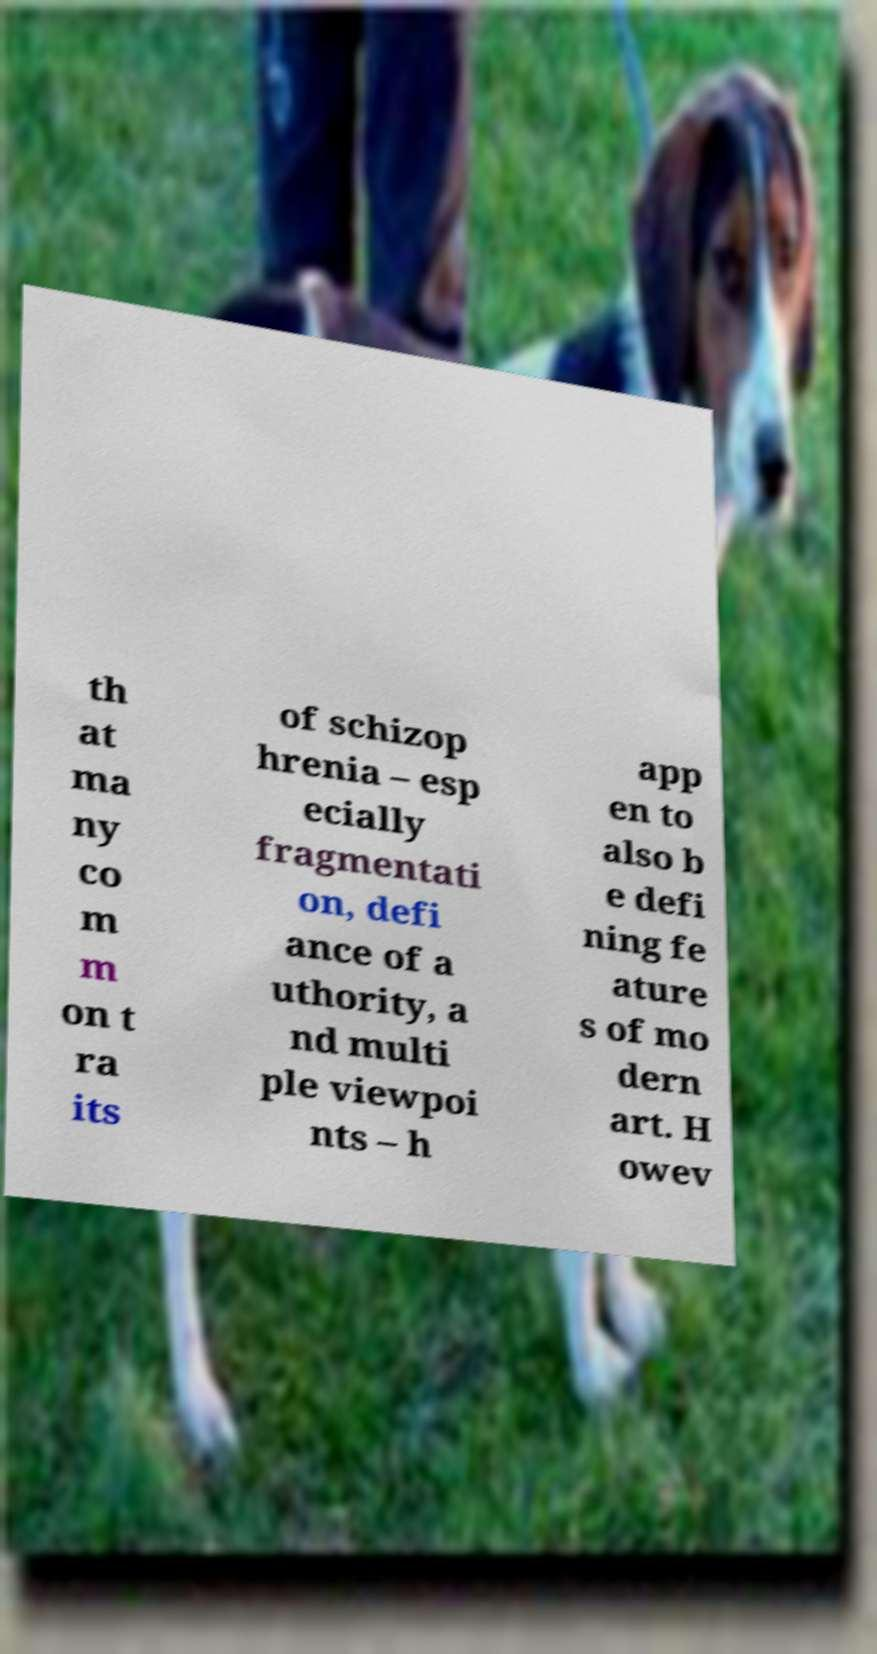For documentation purposes, I need the text within this image transcribed. Could you provide that? th at ma ny co m m on t ra its of schizop hrenia – esp ecially fragmentati on, defi ance of a uthority, a nd multi ple viewpoi nts – h app en to also b e defi ning fe ature s of mo dern art. H owev 